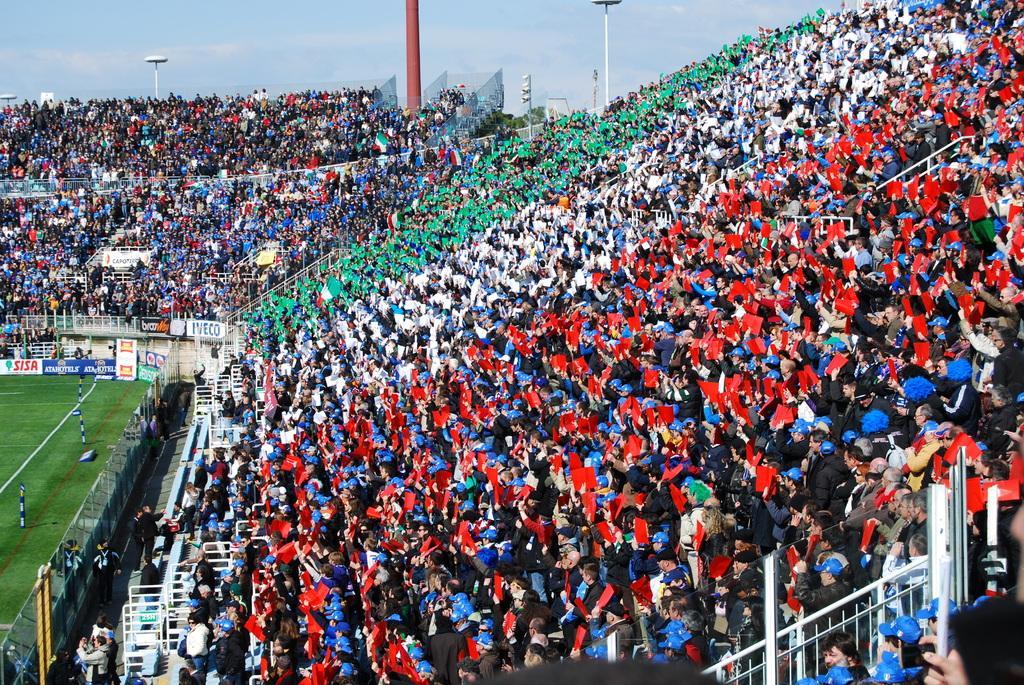Can you describe this image briefly? In this picture I can see there is a playground and there are huge number of audience sitting at right sides and they are wearing red, white and green shirts, it looks like they are representing the teams. There are poles and the sky is clear. 